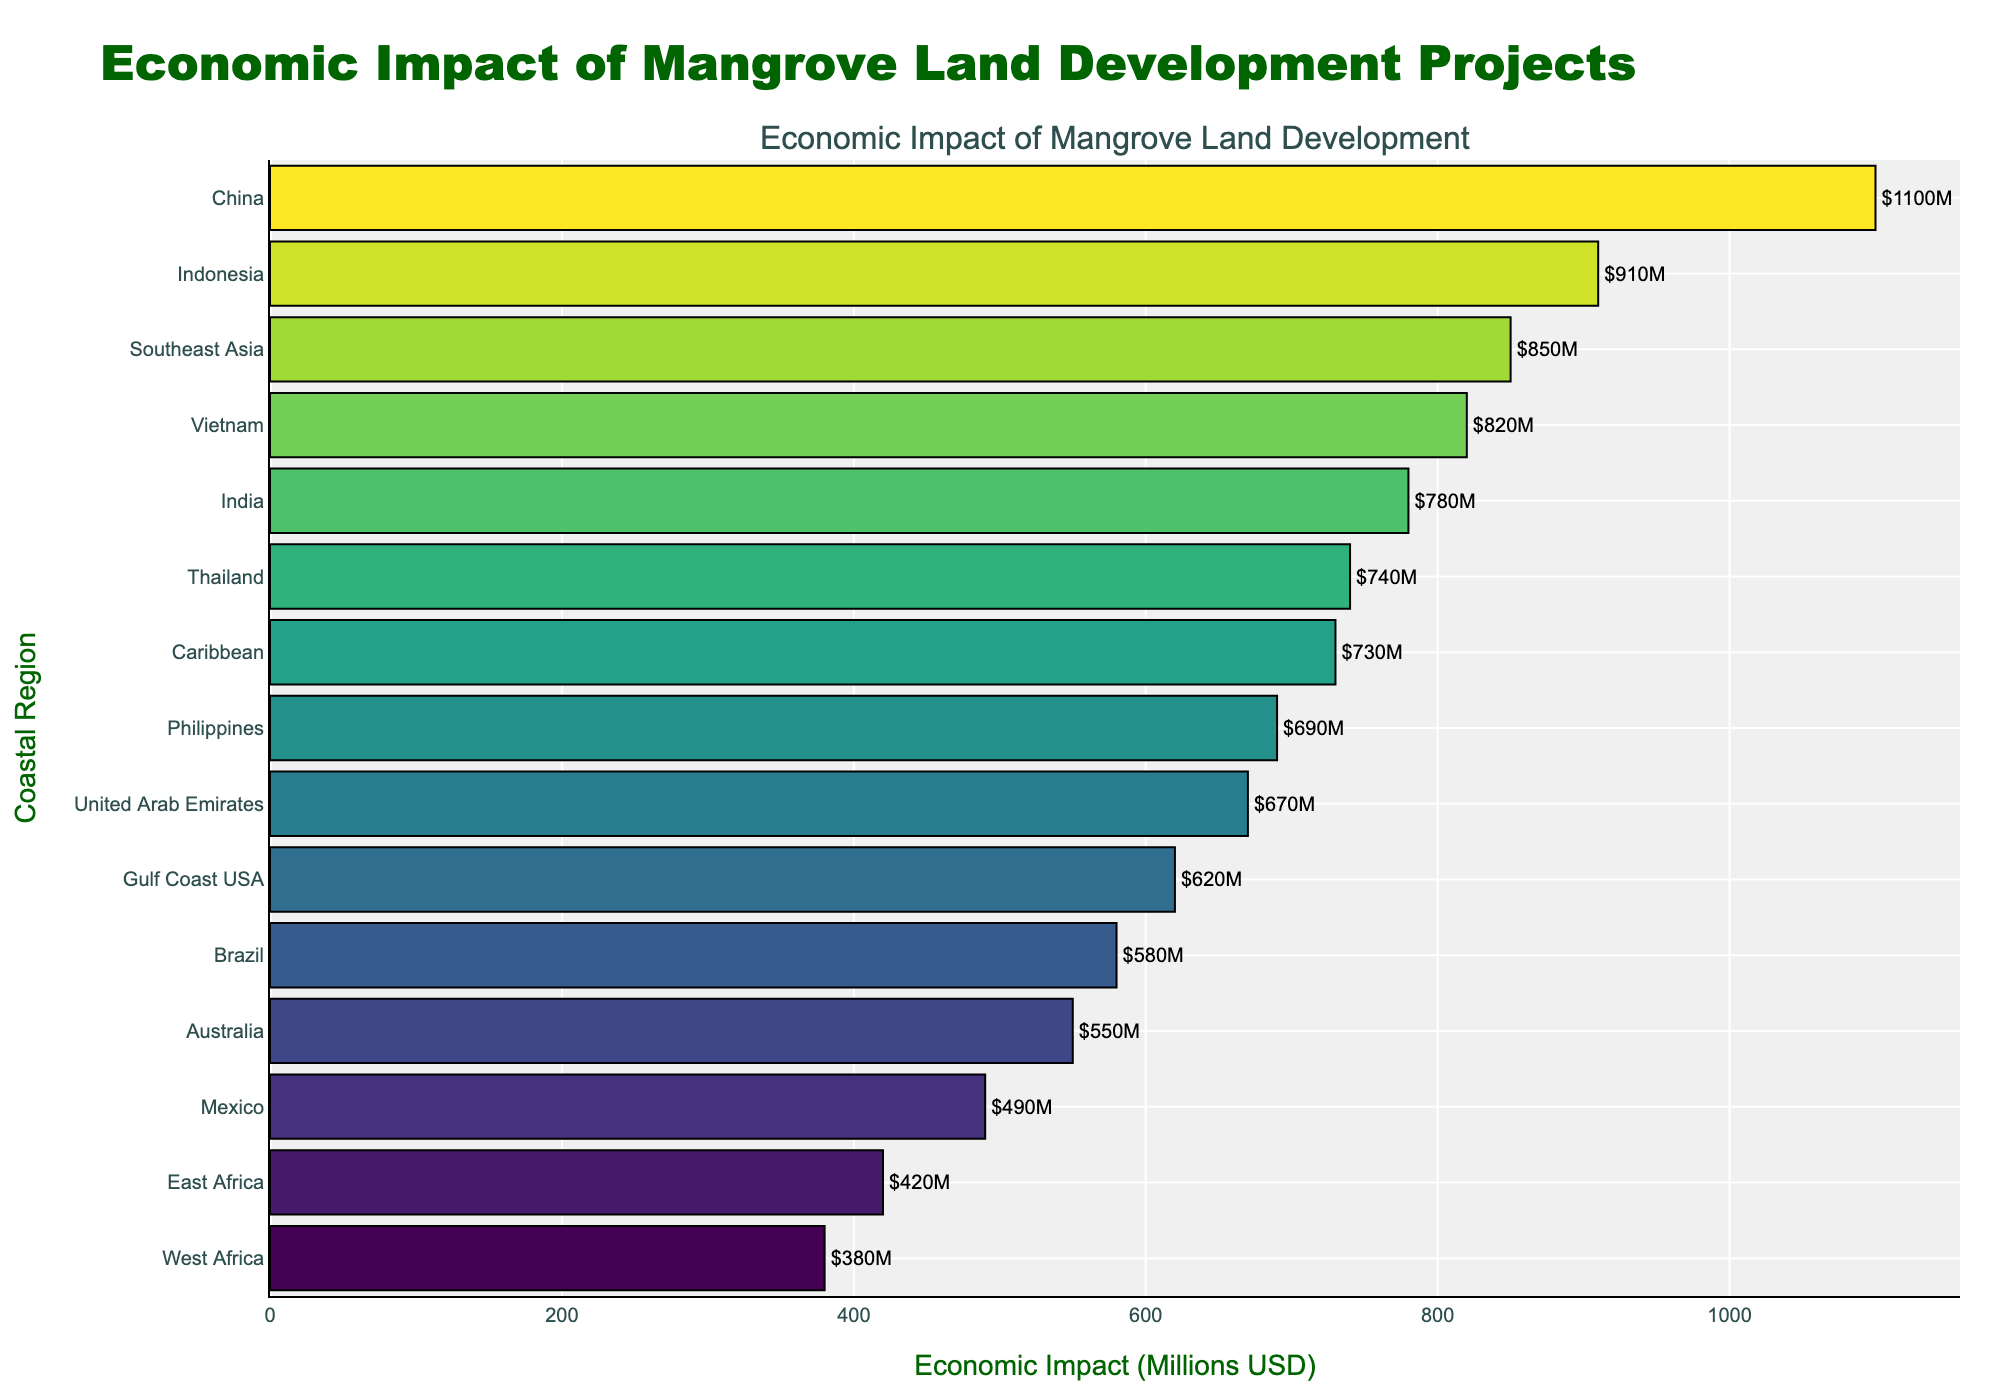Which region has the highest economic impact from mangrove land development? The region with the highest economic impact is indicated by the longest bar. From the chart, China has the longest bar, representing the highest value.
Answer: China Which region has the lowest economic impact from mangrove land development? The region with the lowest economic impact is indicated by the shortest bar. From the chart, West Africa has the shortest bar, representing the lowest value.
Answer: West Africa What is the sum of the economic impacts of the regions with the highest and lowest values? China has the highest value at 1100 million USD, and West Africa has the lowest at 380 million USD. Adding these two values gives 1100 + 380 = 1480.
Answer: 1480 million USD Which regions have an economic impact greater than 800 million USD? To find regions with more than 800 million USD impact, look for bars extending beyond the 800 million USD mark. The regions meeting this criterion are China, Indonesia, Vietnam, India, Southeast Asia, and Thailand.
Answer: China, Indonesia, Vietnam, India, Southeast Asia, Thailand What is the average economic impact of the regions located in Asia? Specifically include Southeast Asia, Indonesia, China, United Arab Emirates, Vietnam, Philippines, and Thailand. Add the economic impacts of the Asian regions: 850 (Southeast Asia) + 910 (Indonesia) + 1100 (China) + 670 (United Arab Emirates) + 820 (Vietnam) + 690 (Philippines) + 740 (Thailand) = 5780. Divide by the number of regions, 5780 / 7 = 826 million USD.
Answer: 826 million USD Which region has an economic impact closest to the overall average value? Calculate the overall average by summing all impacts and dividing by the number of regions. Total = 850 + 620 + 730 + 420 + 580 + 910 + 490 + 780 + 550 + 380 + 1100 + 670 + 820 + 690 + 740 = 10230. Average impact = 10230/15 = 682 million USD. The region with an impact closest to 682 million USD is the Philippines with 690 million USD.
Answer: Philippines How does the economic impact of Gulf Coast USA compare to India? The economic impact for Gulf Coast USA is 620 million USD and for India is 780 million USD. By comparing these values, India's impact is higher.
Answer: India is higher Among Brazil, Mexico, and Australia, which region has the highest economic impact, and what is the difference between it and the region with the lowest impact? Compare the economic impacts: Brazil (580), Mexico (490), Australia (550). Brazil has the highest at 580 million USD. The lowest is Mexico at 490 million USD. The difference is 580 - 490 = 90.
Answer: Brazil, 90 million USD What is the combined economic impact of the Caribbean and East African regions? Sum the economic impacts of the Caribbean (730 million USD) and East Africa (420 million USD): 730 + 420 = 1150.
Answer: 1150 million USD 